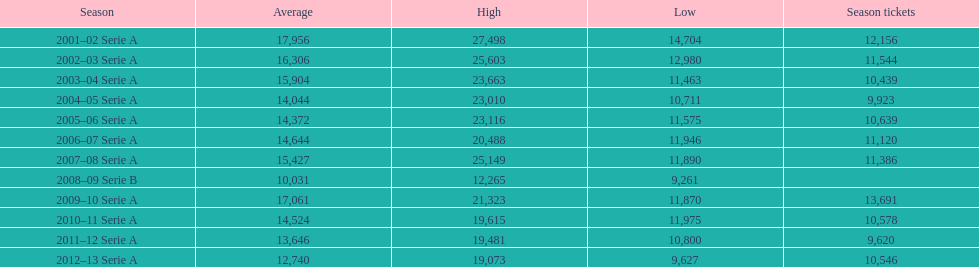What was the mean in 2001? 17,956. Could you help me parse every detail presented in this table? {'header': ['Season', 'Average', 'High', 'Low', 'Season tickets'], 'rows': [['2001–02 Serie A', '17,956', '27,498', '14,704', '12,156'], ['2002–03 Serie A', '16,306', '25,603', '12,980', '11,544'], ['2003–04 Serie A', '15,904', '23,663', '11,463', '10,439'], ['2004–05 Serie A', '14,044', '23,010', '10,711', '9,923'], ['2005–06 Serie A', '14,372', '23,116', '11,575', '10,639'], ['2006–07 Serie A', '14,644', '20,488', '11,946', '11,120'], ['2007–08 Serie A', '15,427', '25,149', '11,890', '11,386'], ['2008–09 Serie B', '10,031', '12,265', '9,261', ''], ['2009–10 Serie A', '17,061', '21,323', '11,870', '13,691'], ['2010–11 Serie A', '14,524', '19,615', '11,975', '10,578'], ['2011–12 Serie A', '13,646', '19,481', '10,800', '9,620'], ['2012–13 Serie A', '12,740', '19,073', '9,627', '10,546']]} 